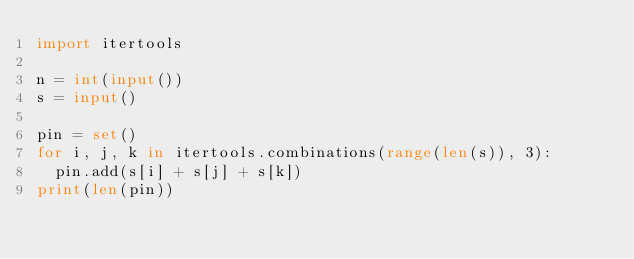<code> <loc_0><loc_0><loc_500><loc_500><_Python_>import itertools

n = int(input())
s = input()

pin = set()
for i, j, k in itertools.combinations(range(len(s)), 3):
  pin.add(s[i] + s[j] + s[k])
print(len(pin))</code> 